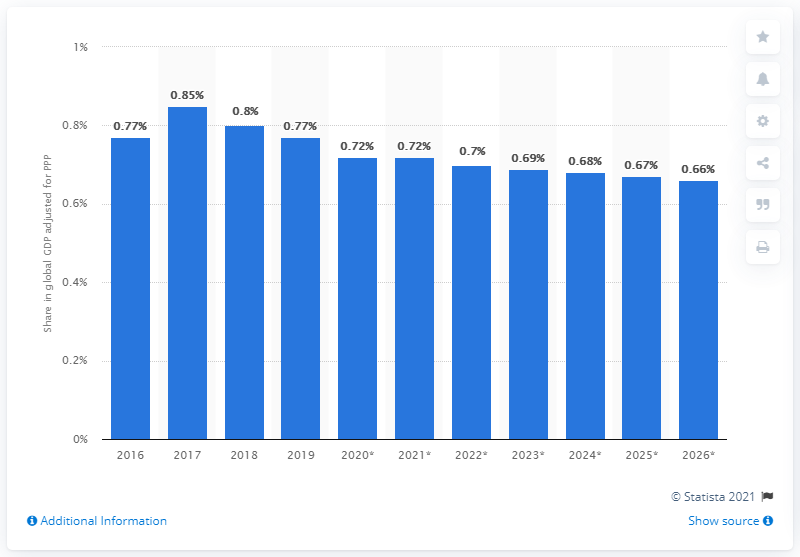Identify some key points in this picture. According to the Global Gross Domestic Product (GDP) adjusted for Purchasing Power Parity in 2019, Argentina's share was 0.77. 